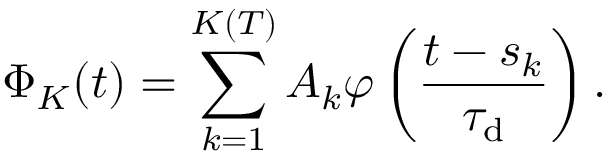Convert formula to latex. <formula><loc_0><loc_0><loc_500><loc_500>\Phi _ { K } ( t ) = \sum _ { k = 1 } ^ { K ( T ) } A _ { k } \varphi \left ( \frac { t - s _ { k } } { { \tau _ { d } } } \right ) .</formula> 